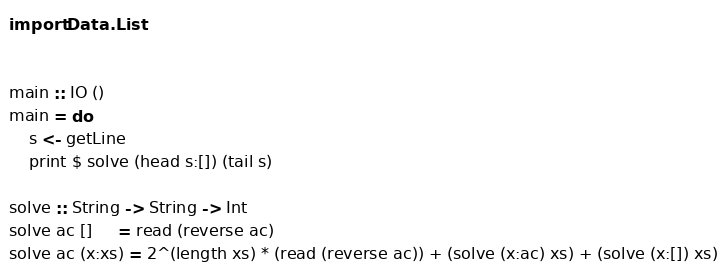Convert code to text. <code><loc_0><loc_0><loc_500><loc_500><_Haskell_>import Data.List


main :: IO ()
main = do
    s <- getLine
    print $ solve (head s:[]) (tail s)

solve :: String -> String -> Int
solve ac []     = read (reverse ac)
solve ac (x:xs) = 2^(length xs) * (read (reverse ac)) + (solve (x:ac) xs) + (solve (x:[]) xs)



</code> 